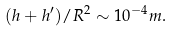<formula> <loc_0><loc_0><loc_500><loc_500>( h + h ^ { \prime } ) / R ^ { 2 } \sim 1 0 ^ { - 4 } m .</formula> 